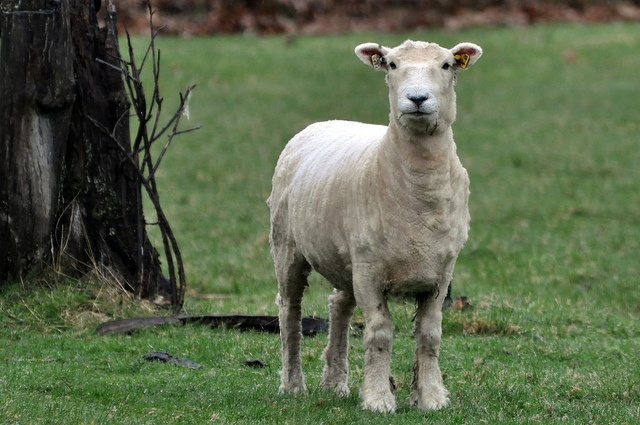Describe the objects in this image and their specific colors. I can see a sheep in black, darkgray, gray, and lightgray tones in this image. 